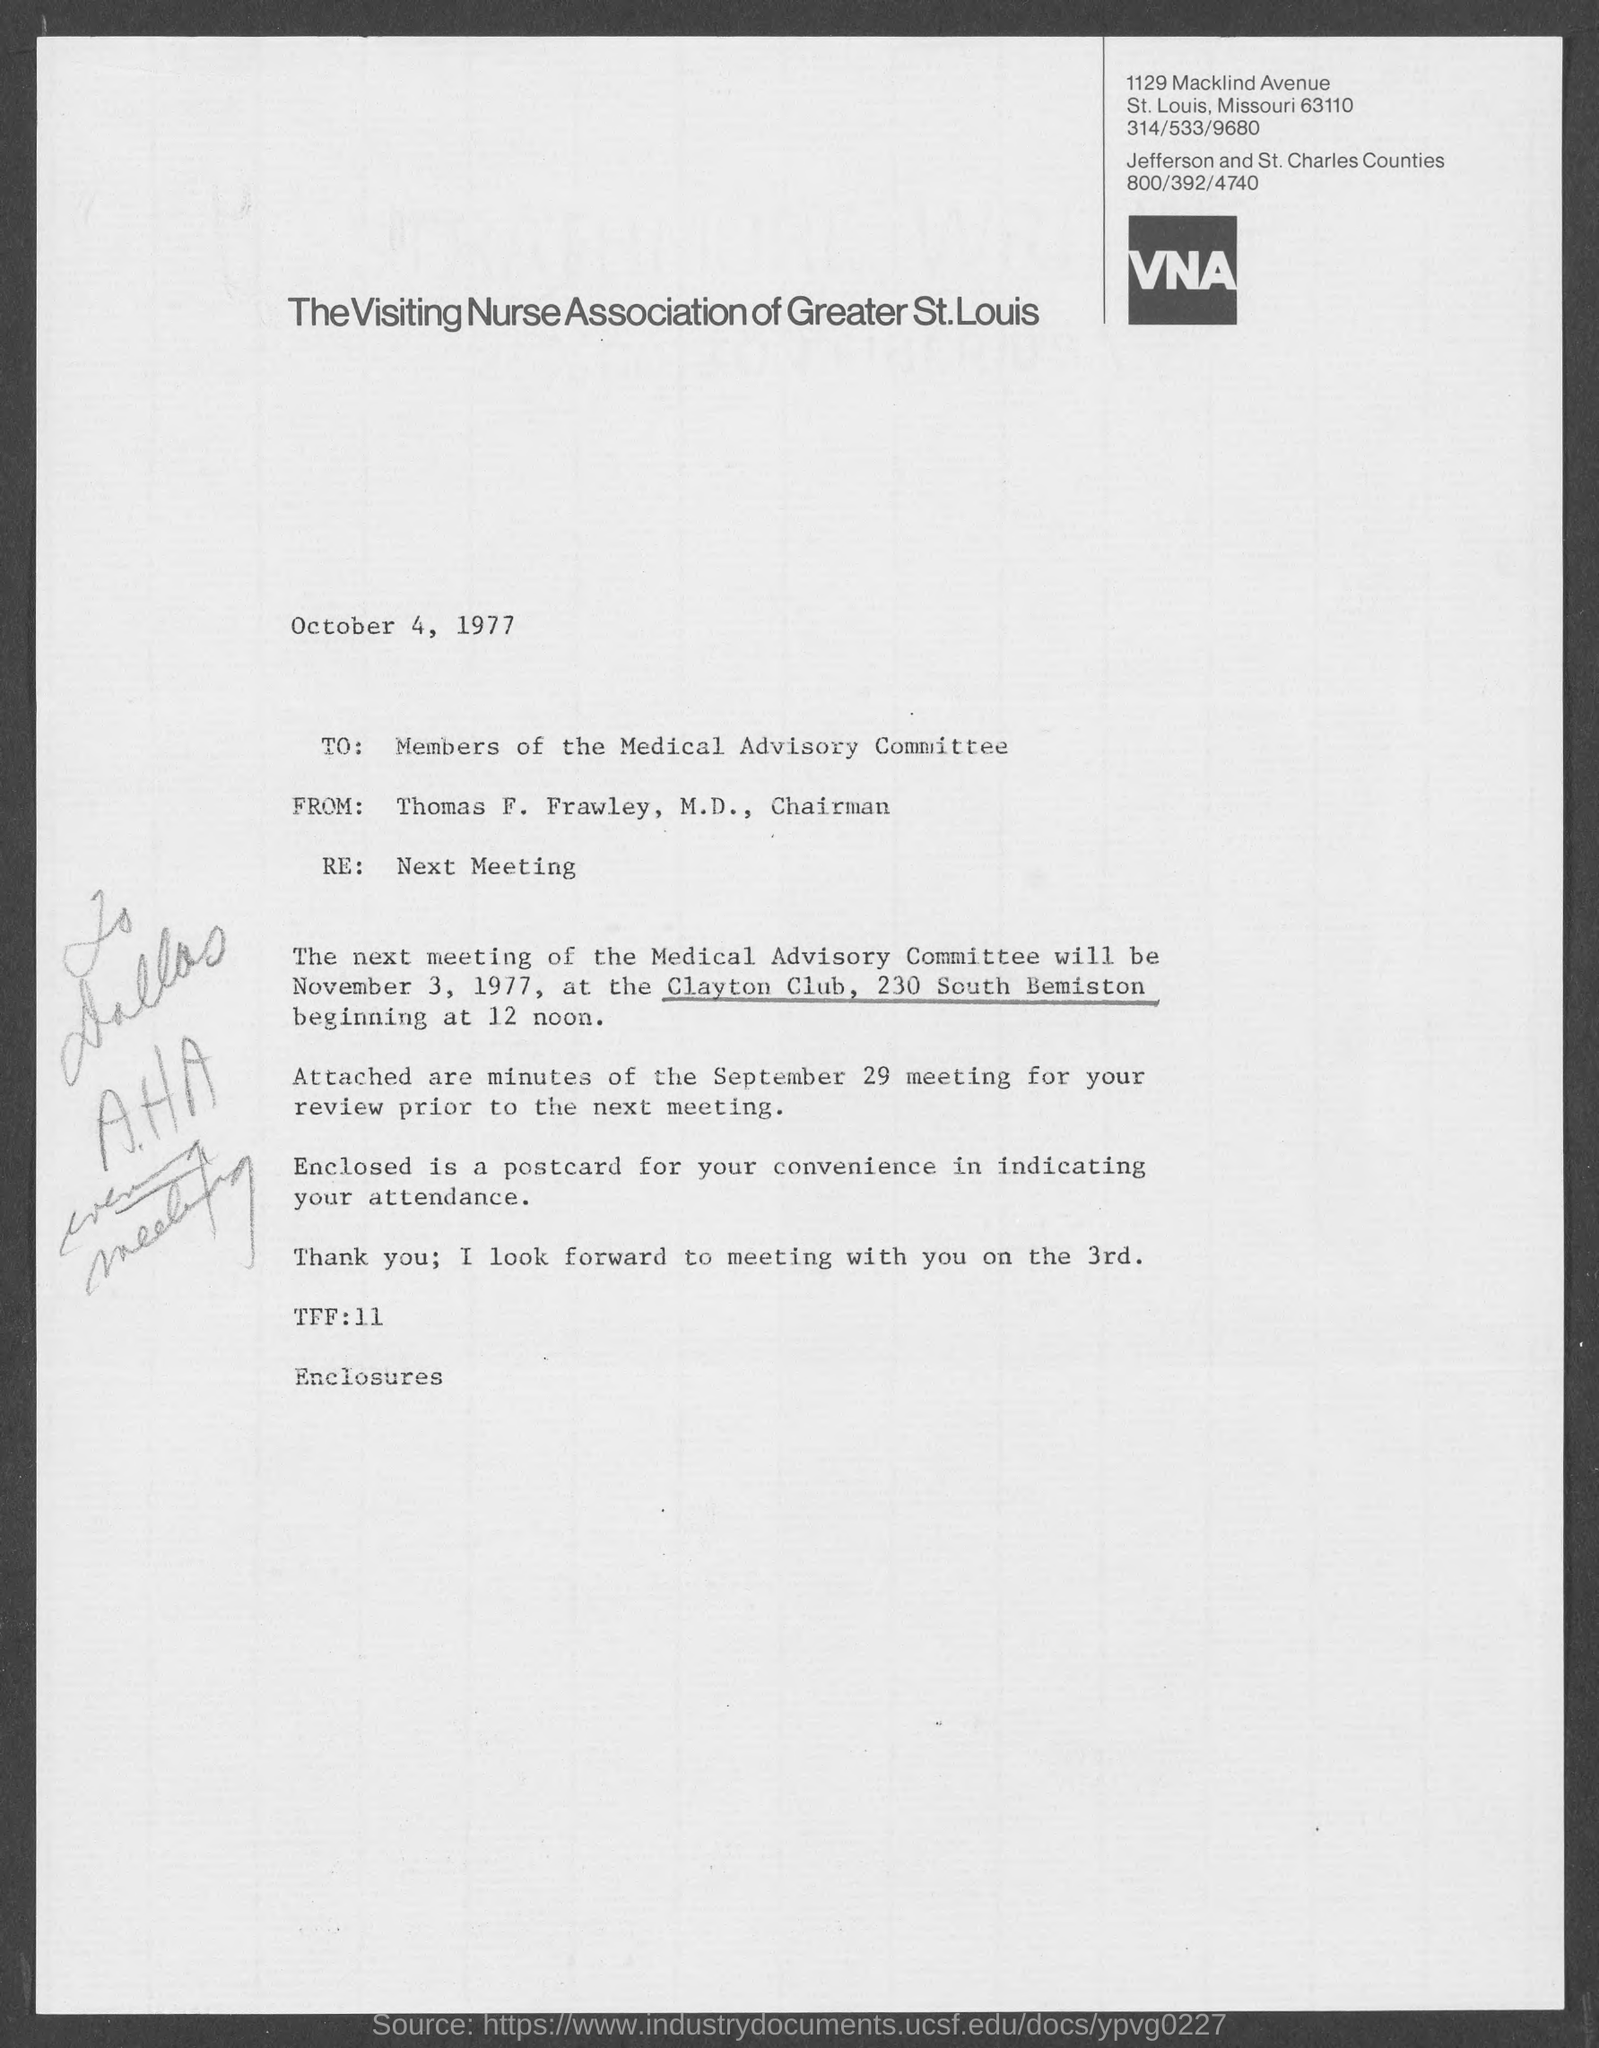Point out several critical features in this image. On October 4, 1977, the date of intimation was. The next meeting of the Medical Advisory Committee will be held at the Clayton Club, located at 230 South Bemiston. Thomas F. Frawley, M.D., wrote this letter. The next meeting of the Medical Advisory Committee will be held on November 3, 1977. The recipient of this letter is the Medical Advisory Committee. 